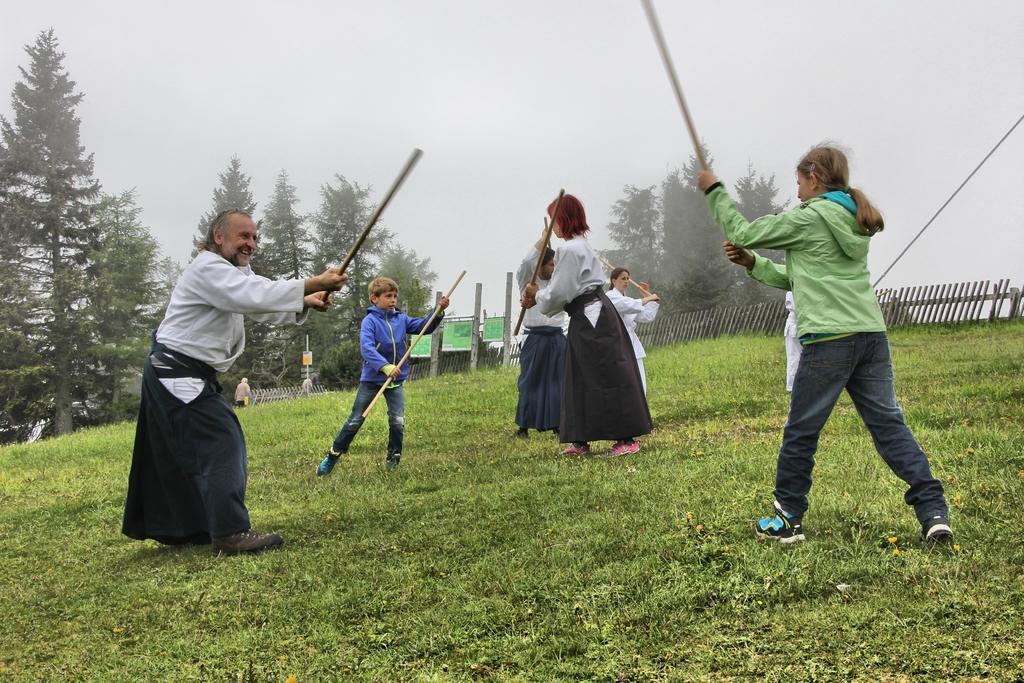How would you summarize this image in a sentence or two? In this picture we can see some people standing and playing with sticks, at the bottom there is grass, we can see some trees in the background, there is a fencing here, we can see the sky at the top of the picture. 